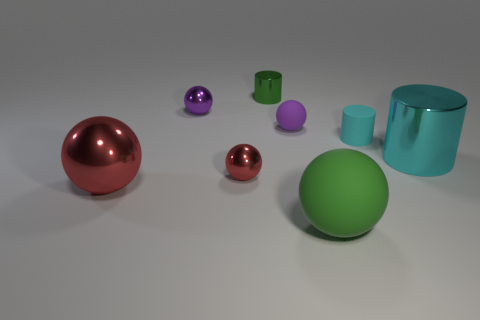How many rubber objects are brown cylinders or purple objects?
Your response must be concise. 1. There is a big rubber thing; is its shape the same as the tiny object that is on the right side of the tiny rubber sphere?
Make the answer very short. No. Are there more purple things that are in front of the large red ball than large red shiny spheres that are behind the large cyan object?
Provide a short and direct response. No. Is there anything else that has the same color as the large metal cylinder?
Provide a short and direct response. Yes. There is a large ball that is left of the green object that is on the right side of the tiny green object; are there any matte things on the left side of it?
Your answer should be very brief. No. There is a big metallic thing that is to the left of the large green matte object; is it the same shape as the tiny cyan matte object?
Your response must be concise. No. Is the number of large red objects that are in front of the large green rubber object less than the number of large shiny cylinders behind the purple shiny thing?
Your answer should be very brief. No. What is the material of the small green thing?
Give a very brief answer. Metal. There is a big rubber thing; does it have the same color as the big metallic object that is left of the large cyan metallic cylinder?
Ensure brevity in your answer.  No. How many large shiny things are in front of the big metal cylinder?
Your answer should be very brief. 1. 